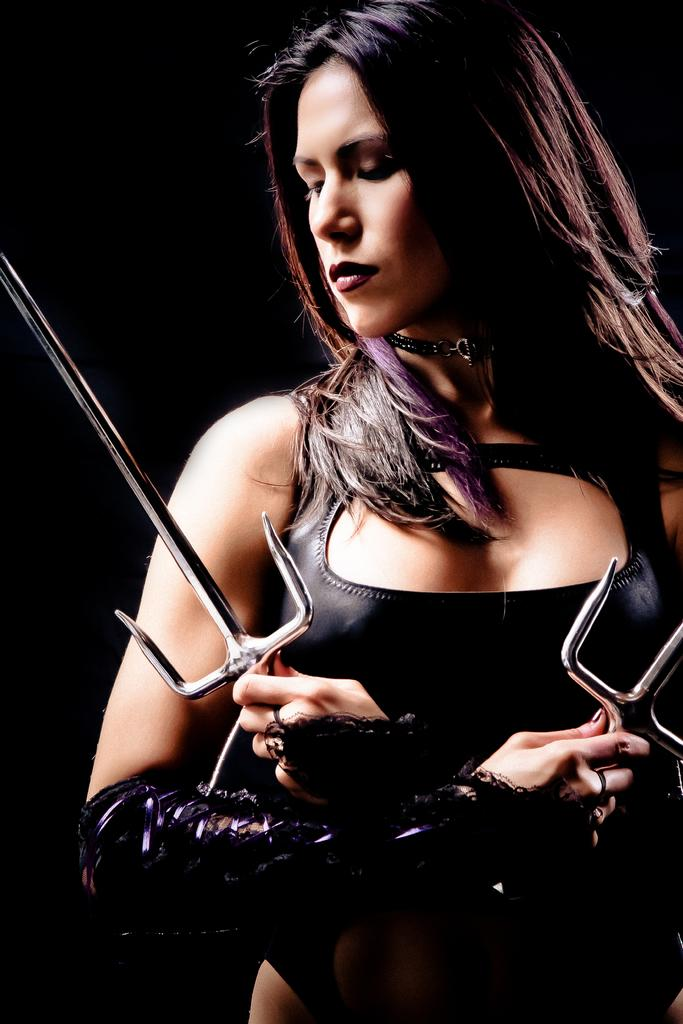Who is the main subject in the image? There is a woman in the image. What can be observed about the background of the image? The background of the image is dark. What type of bait is the beggar using to attract the attention of the woman in the image? There is no beggar or bait present in the image. What can be seen in the woman's mouth in the image? There is no information about the woman's teeth or mouth in the image. 